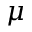Convert formula to latex. <formula><loc_0><loc_0><loc_500><loc_500>\mu</formula> 